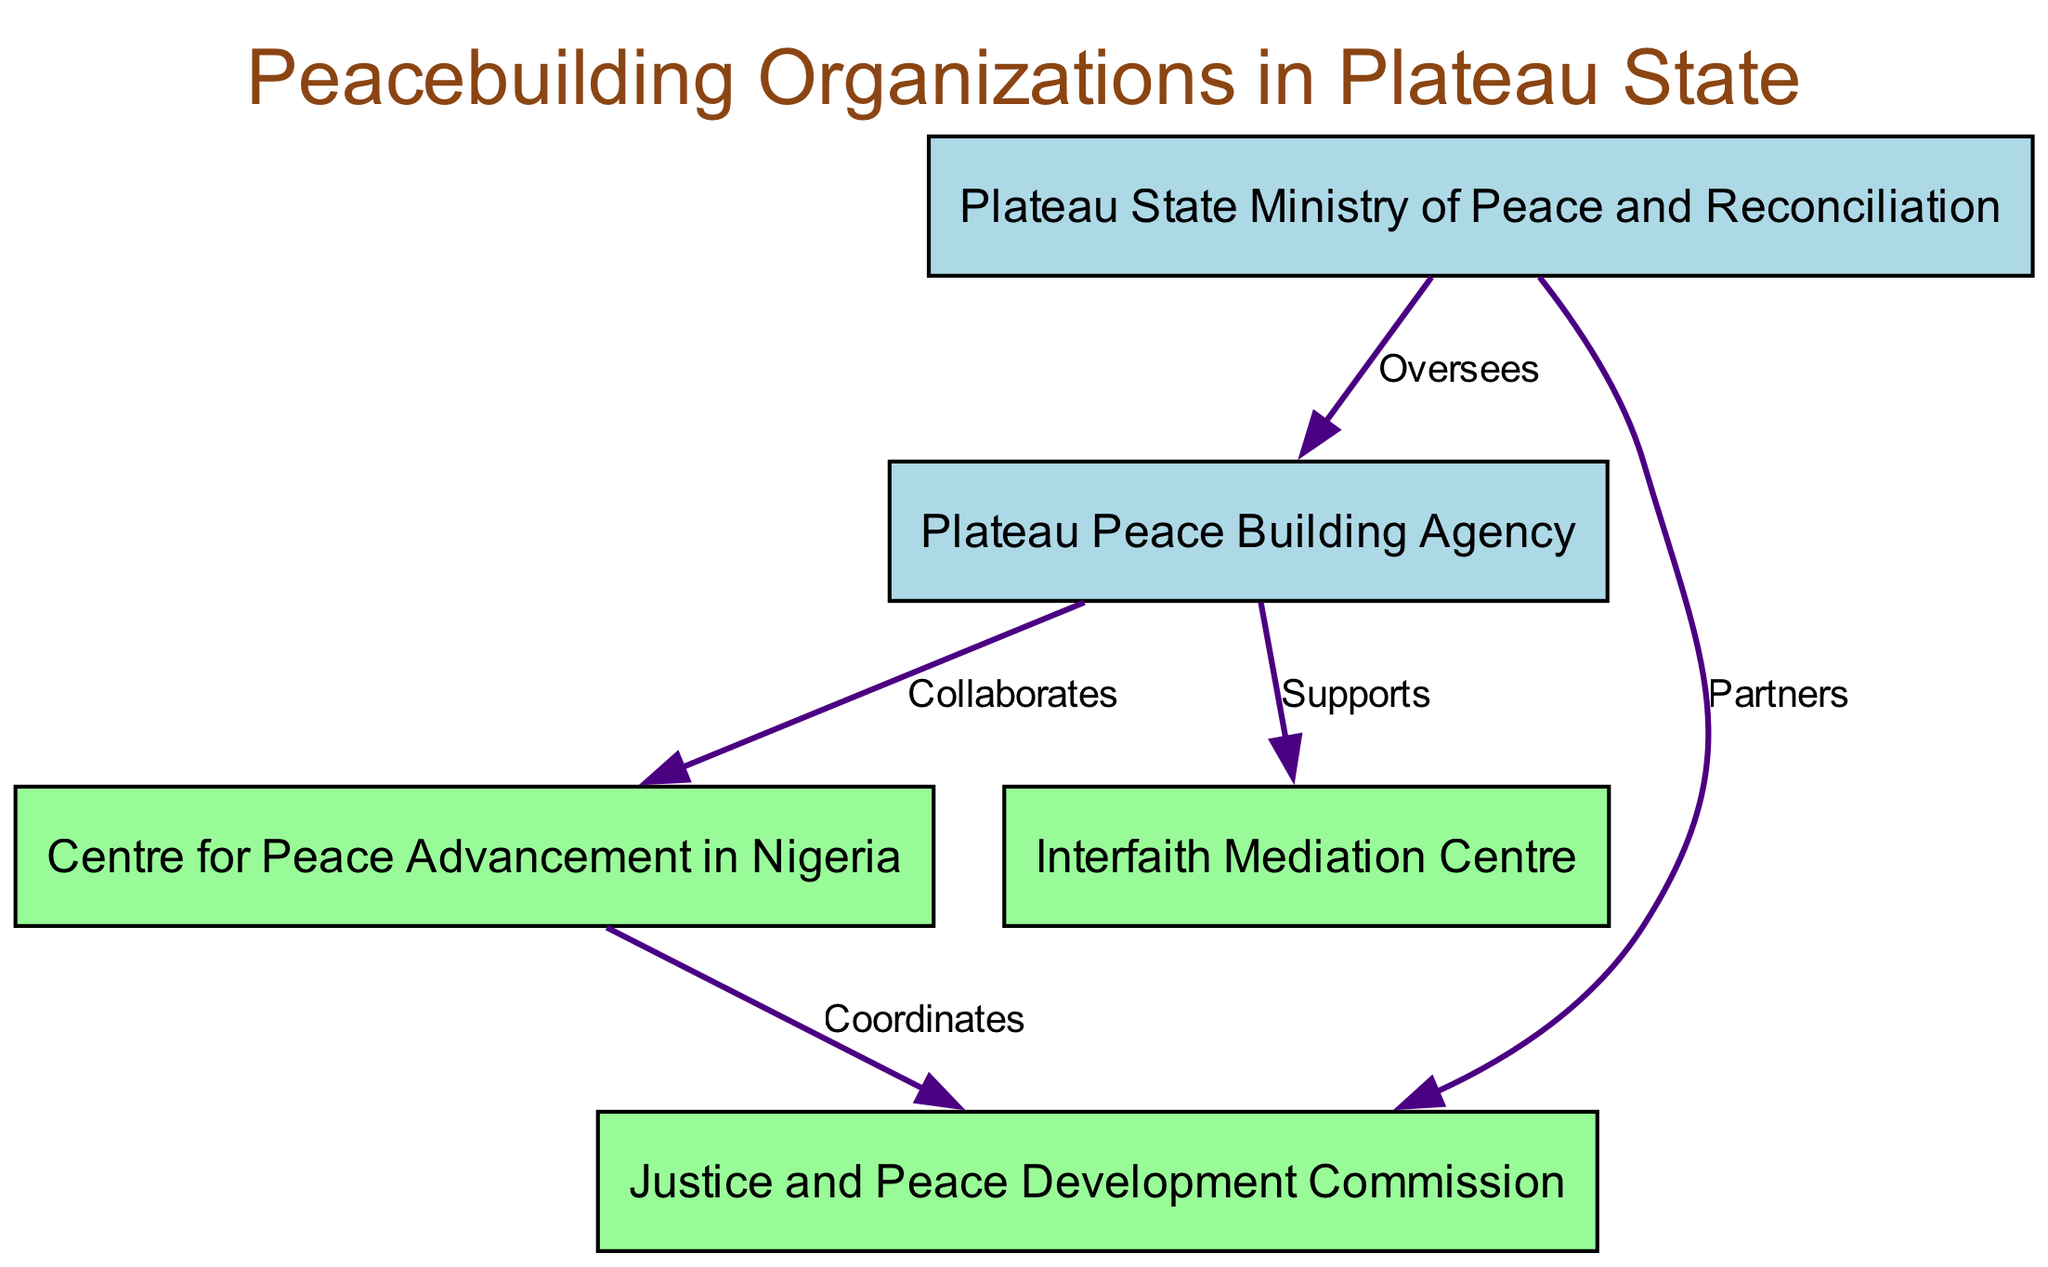What is the total number of nodes in the diagram? The diagram includes five different entities: Plateau Peace Building Agency, Centre for Peace Advancement in Nigeria, Interfaith Mediation Centre, Plateau State Ministry of Peace and Reconciliation, and Justice and Peace Development Commission. Count them to find the total number of nodes.
Answer: 5 Which organization is supported by the Plateau Peace Building Agency? The "Supports" relationship indicates that Plateau Peace Building Agency directly supports the Interfaith Mediation Centre. This connection is clearly marked in the diagram.
Answer: Interfaith Mediation Centre How many local NGOs are represented in the diagram? There are three local NGOs listed: Centre for Peace Advancement in Nigeria, Interfaith Mediation Centre, and Justice and Peace Development Commission. Subtracting the government agencies gives us the count.
Answer: 3 What is the relationship between the Plateau State Ministry of Peace and Reconciliation and the Plateau Peace Building Agency? The relationship is indicated as "Oversees," which shows that the Ministry provides oversight to the Peace Building Agency. This implies a supervisory role.
Answer: Oversees Which two entities coordinate with each other according to the diagram? The Centre for Peace Advancement in Nigeria is indicated to coordinate activities with the Justice and Peace Development Commission. This is shown explicitly through the "Coordinates" connection.
Answer: Centre for Peace Advancement in Nigeria and Justice and Peace Development Commission What color represents the Local NGOs in this diagram? The Local NGOs are represented in pale green color, which is assigned for their nodes to distinguish them from government agencies visually.
Answer: Pale Green Which organization partners with the Plateau State Ministry of Peace and Reconciliation? The Justice and Peace Development Commission is shown as a partner to the Plateau State Ministry of Peace and Reconciliation, as indicated by the "Partners" label in the connections.
Answer: Justice and Peace Development Commission How many connections are there in total between the nodes? By counting the connections from the provided data, we find there are five connections represented in the diagram.
Answer: 5 